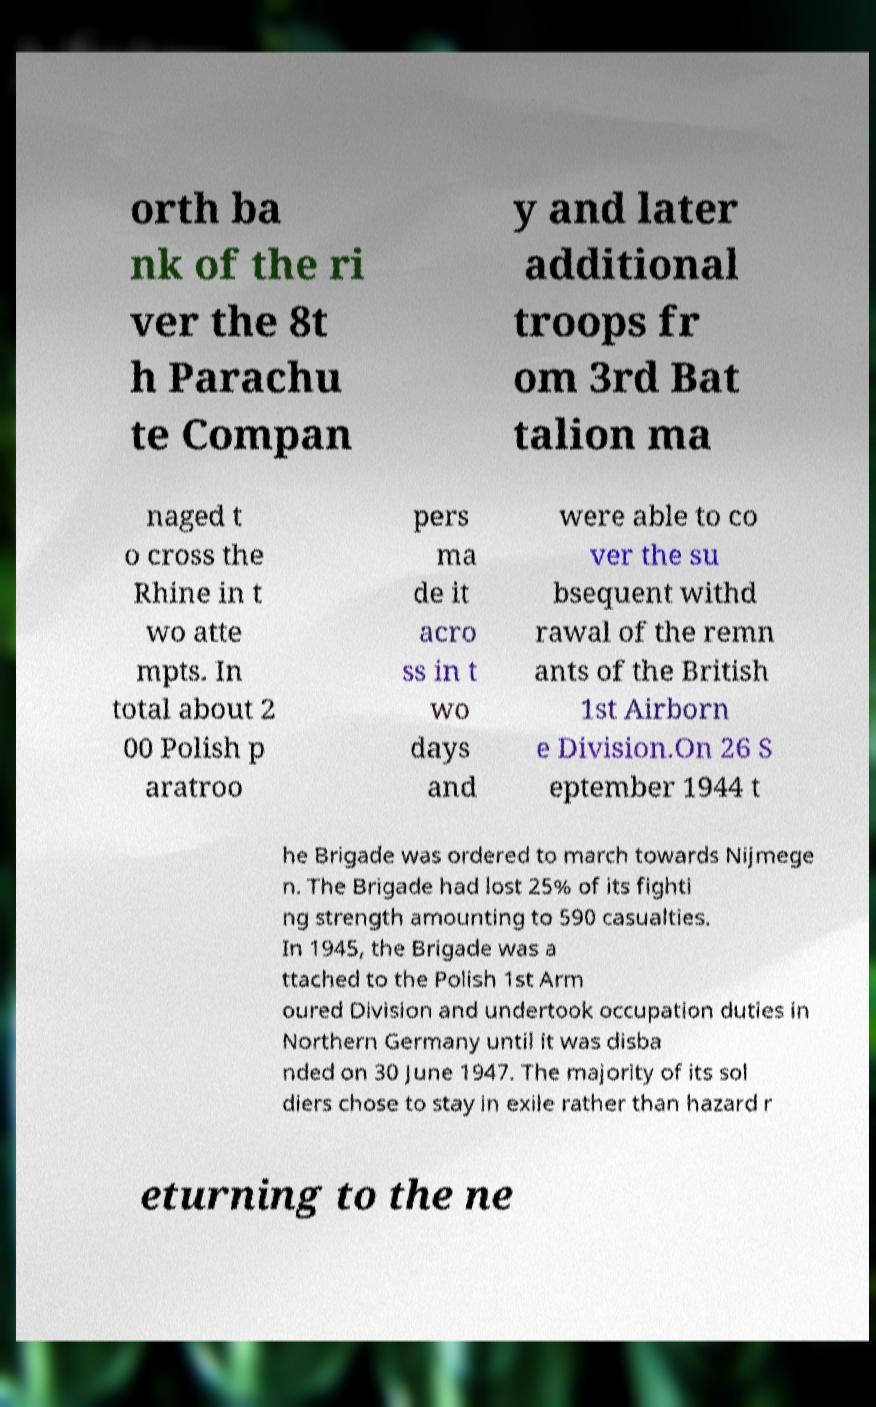Please identify and transcribe the text found in this image. orth ba nk of the ri ver the 8t h Parachu te Compan y and later additional troops fr om 3rd Bat talion ma naged t o cross the Rhine in t wo atte mpts. In total about 2 00 Polish p aratroo pers ma de it acro ss in t wo days and were able to co ver the su bsequent withd rawal of the remn ants of the British 1st Airborn e Division.On 26 S eptember 1944 t he Brigade was ordered to march towards Nijmege n. The Brigade had lost 25% of its fighti ng strength amounting to 590 casualties. In 1945, the Brigade was a ttached to the Polish 1st Arm oured Division and undertook occupation duties in Northern Germany until it was disba nded on 30 June 1947. The majority of its sol diers chose to stay in exile rather than hazard r eturning to the ne 